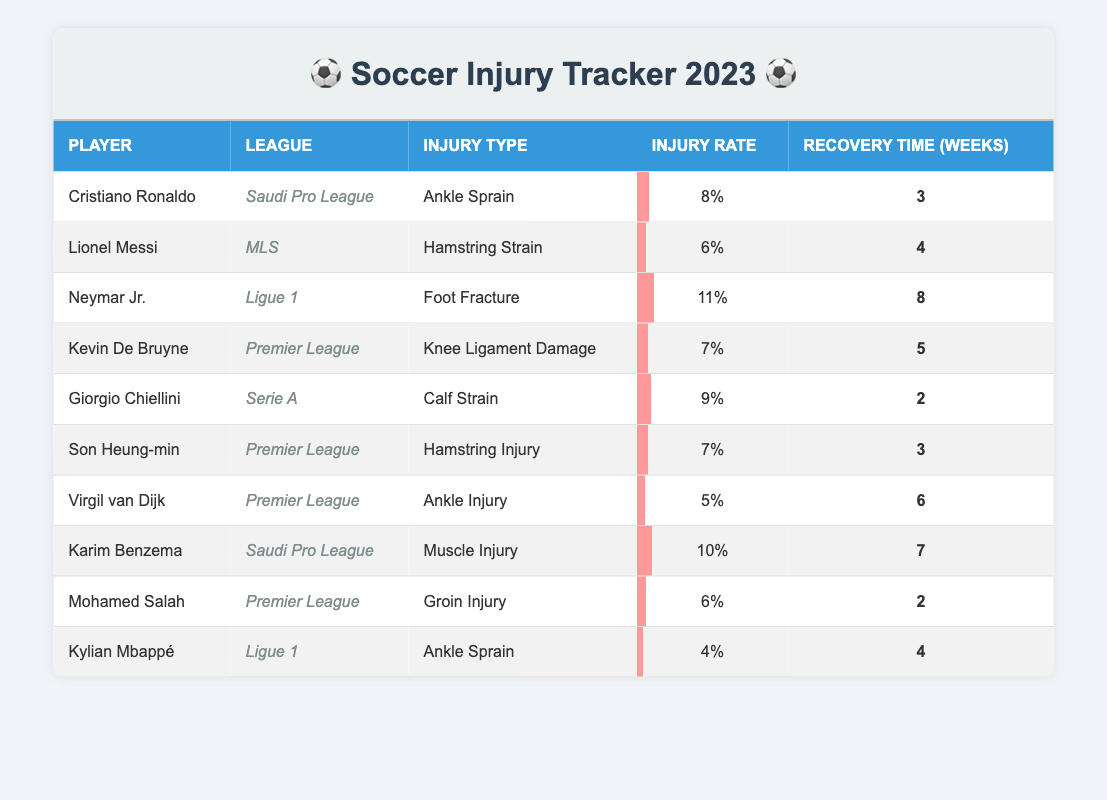What is the highest injury rate among the players listed? Looking through the injury rates provided, Neymar Jr. has the highest rate at 11%.
Answer: 11% Which player has the longest recovery time, and how many weeks is it? By examining the recovery times, Neymar Jr. has the longest recovery time of 8 weeks.
Answer: 8 weeks Does Virgil van Dijk have a higher injury rate than Cristiano Ronaldo? Comparing their injury rates, Virgil van Dijk's rate is 5%, while Cristiano Ronaldo's is 8%, so Virgil does not have a higher rate.
Answer: No What is the average recovery time for players in the Premier League? The recovery times for Premier League players are 5, 3, and 2 weeks. Summing these gives 5 + 3 + 2 = 10 weeks. Dividing by 3 players yields an average of 10/3 = 3.33 weeks.
Answer: 3.33 weeks Which league has the most players listed in this table? The Premier League has 4 players, which is the highest among all leagues in the table (Saudi Pro League has 3, while the others have less).
Answer: Premier League Is there any player listed in the table who plays in both Ligue 1 and the Premier League? Checking the players in the table, there are no players who belong to both Ligue 1 and the Premier League.
Answer: No What is the difference in recovery time between the player with the longest and the player with the shortest recovery time? The longest recovery time is 8 weeks (Neymar Jr.) and the shortest is 2 weeks (Mohamed Salah). The difference is 8 - 2 = 6 weeks.
Answer: 6 weeks Which player has an injury type categorized as a 'Muscle Injury'? Karim Benzema is the only player listed with the injury type categorized as 'Muscle Injury'.
Answer: Karim Benzema What percentage of players listed have an injury recovery time of 3 weeks or more? There are 10 players, and 7 of them have a recovery time of 3 weeks or more (3, 4, 5, 6, 7, 8). Thus, the percentage is (7/10)*100 = 70%.
Answer: 70% 